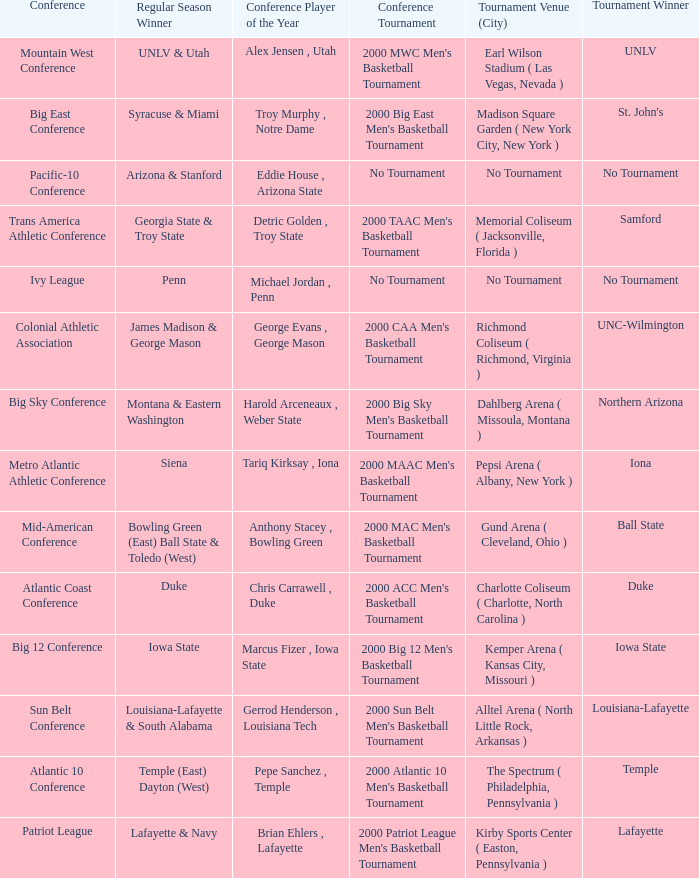What is the venue and city where the 2000 MWC Men's Basketball Tournament? Earl Wilson Stadium ( Las Vegas, Nevada ). Give me the full table as a dictionary. {'header': ['Conference', 'Regular Season Winner', 'Conference Player of the Year', 'Conference Tournament', 'Tournament Venue (City)', 'Tournament Winner'], 'rows': [['Mountain West Conference', 'UNLV & Utah', 'Alex Jensen , Utah', "2000 MWC Men's Basketball Tournament", 'Earl Wilson Stadium ( Las Vegas, Nevada )', 'UNLV'], ['Big East Conference', 'Syracuse & Miami', 'Troy Murphy , Notre Dame', "2000 Big East Men's Basketball Tournament", 'Madison Square Garden ( New York City, New York )', "St. John's"], ['Pacific-10 Conference', 'Arizona & Stanford', 'Eddie House , Arizona State', 'No Tournament', 'No Tournament', 'No Tournament'], ['Trans America Athletic Conference', 'Georgia State & Troy State', 'Detric Golden , Troy State', "2000 TAAC Men's Basketball Tournament", 'Memorial Coliseum ( Jacksonville, Florida )', 'Samford'], ['Ivy League', 'Penn', 'Michael Jordan , Penn', 'No Tournament', 'No Tournament', 'No Tournament'], ['Colonial Athletic Association', 'James Madison & George Mason', 'George Evans , George Mason', "2000 CAA Men's Basketball Tournament", 'Richmond Coliseum ( Richmond, Virginia )', 'UNC-Wilmington'], ['Big Sky Conference', 'Montana & Eastern Washington', 'Harold Arceneaux , Weber State', "2000 Big Sky Men's Basketball Tournament", 'Dahlberg Arena ( Missoula, Montana )', 'Northern Arizona'], ['Metro Atlantic Athletic Conference', 'Siena', 'Tariq Kirksay , Iona', "2000 MAAC Men's Basketball Tournament", 'Pepsi Arena ( Albany, New York )', 'Iona'], ['Mid-American Conference', 'Bowling Green (East) Ball State & Toledo (West)', 'Anthony Stacey , Bowling Green', "2000 MAC Men's Basketball Tournament", 'Gund Arena ( Cleveland, Ohio )', 'Ball State'], ['Atlantic Coast Conference', 'Duke', 'Chris Carrawell , Duke', "2000 ACC Men's Basketball Tournament", 'Charlotte Coliseum ( Charlotte, North Carolina )', 'Duke'], ['Big 12 Conference', 'Iowa State', 'Marcus Fizer , Iowa State', "2000 Big 12 Men's Basketball Tournament", 'Kemper Arena ( Kansas City, Missouri )', 'Iowa State'], ['Sun Belt Conference', 'Louisiana-Lafayette & South Alabama', 'Gerrod Henderson , Louisiana Tech', "2000 Sun Belt Men's Basketball Tournament", 'Alltel Arena ( North Little Rock, Arkansas )', 'Louisiana-Lafayette'], ['Atlantic 10 Conference', 'Temple (East) Dayton (West)', 'Pepe Sanchez , Temple', "2000 Atlantic 10 Men's Basketball Tournament", 'The Spectrum ( Philadelphia, Pennsylvania )', 'Temple'], ['Patriot League', 'Lafayette & Navy', 'Brian Ehlers , Lafayette', "2000 Patriot League Men's Basketball Tournament", 'Kirby Sports Center ( Easton, Pennsylvania )', 'Lafayette']]} 